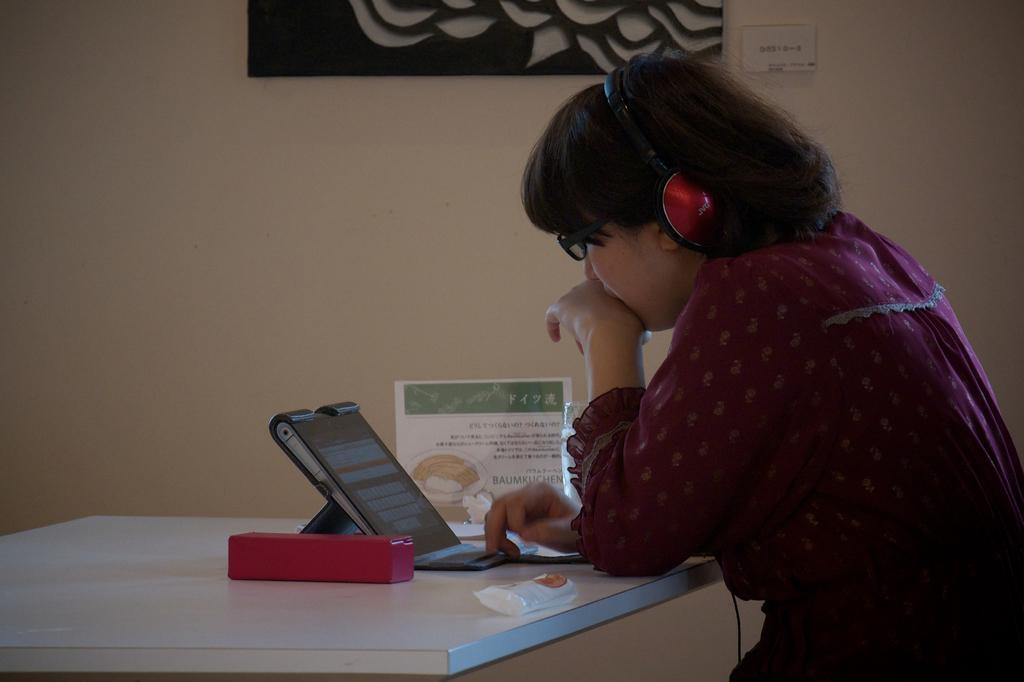How would you summarize this image in a sentence or two? In this image we can see a girl is sitting. In front her, we can see a table. On the table, we can see a laptop and some object. In the background, There is a frame on the wall. 